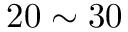<formula> <loc_0><loc_0><loc_500><loc_500>2 0 \sim 3 0 \</formula> 